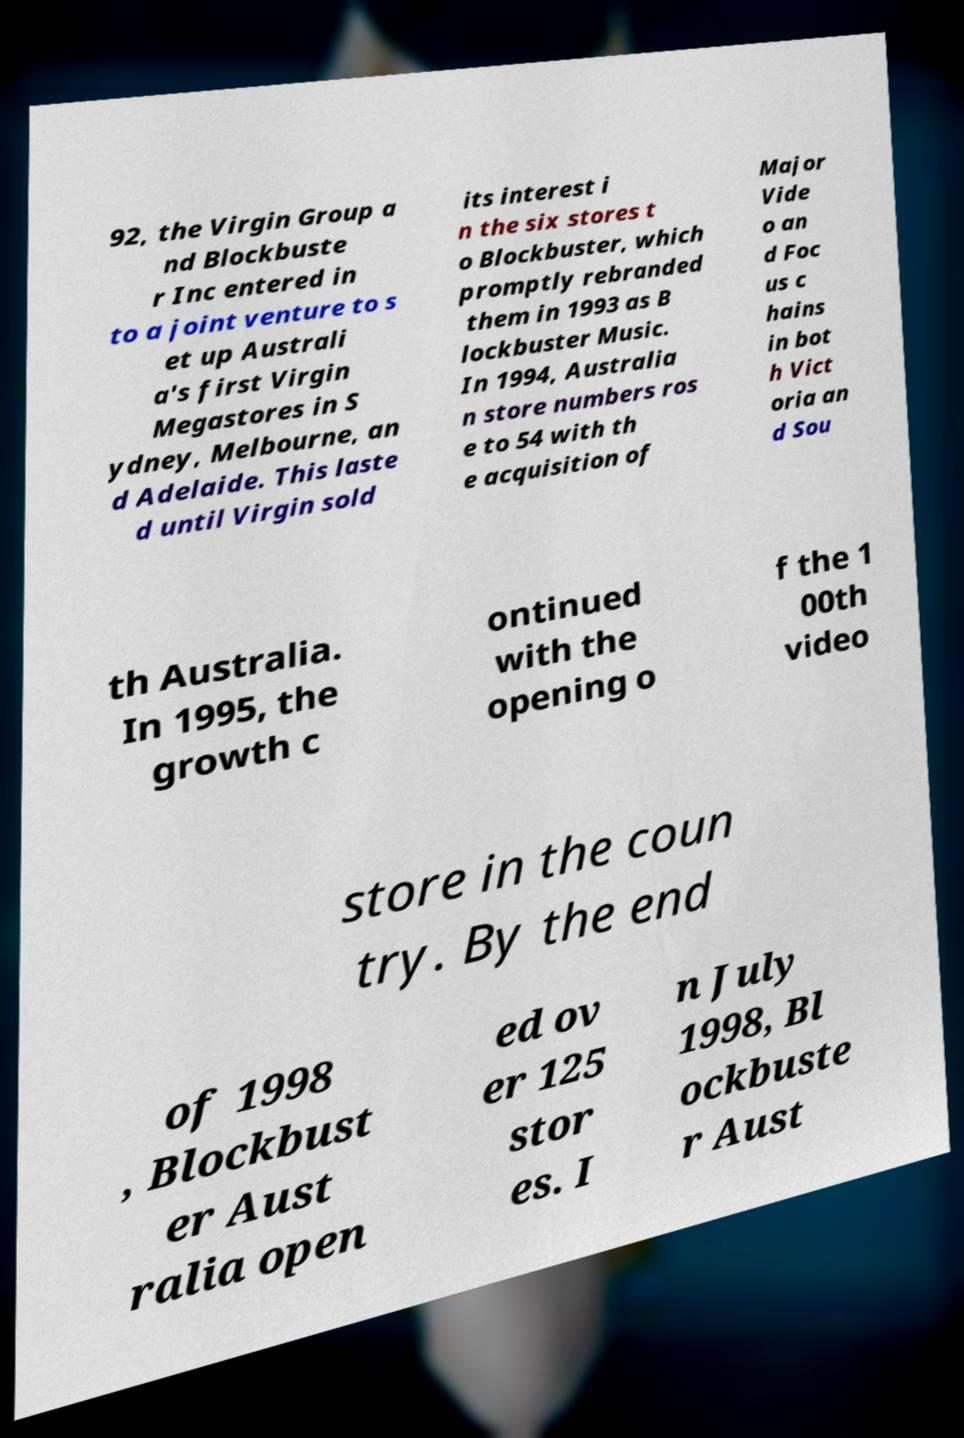I need the written content from this picture converted into text. Can you do that? 92, the Virgin Group a nd Blockbuste r Inc entered in to a joint venture to s et up Australi a's first Virgin Megastores in S ydney, Melbourne, an d Adelaide. This laste d until Virgin sold its interest i n the six stores t o Blockbuster, which promptly rebranded them in 1993 as B lockbuster Music. In 1994, Australia n store numbers ros e to 54 with th e acquisition of Major Vide o an d Foc us c hains in bot h Vict oria an d Sou th Australia. In 1995, the growth c ontinued with the opening o f the 1 00th video store in the coun try. By the end of 1998 , Blockbust er Aust ralia open ed ov er 125 stor es. I n July 1998, Bl ockbuste r Aust 